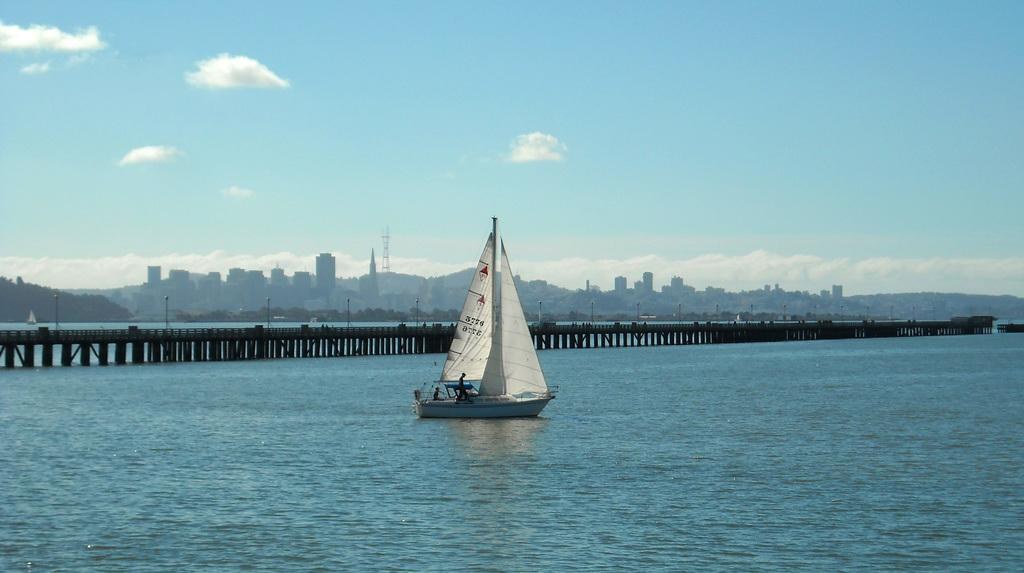What is on the water in the image? There are boats on the water in the image. How many people are present in the image? There are two persons in the image. What type of structures can be seen in the image? There are buildings in the image. What geographical features are visible in the image? There are hills in the image. What type of man-made structure connects two areas in the image? There is a bridge in the image. What can be seen in the background of the image? The sky is visible in the background of the image. What type of leather can be seen on the can in the image? There is no can or leather present in the image. What sound does the horn make in the image? There is no horn present in the image. 